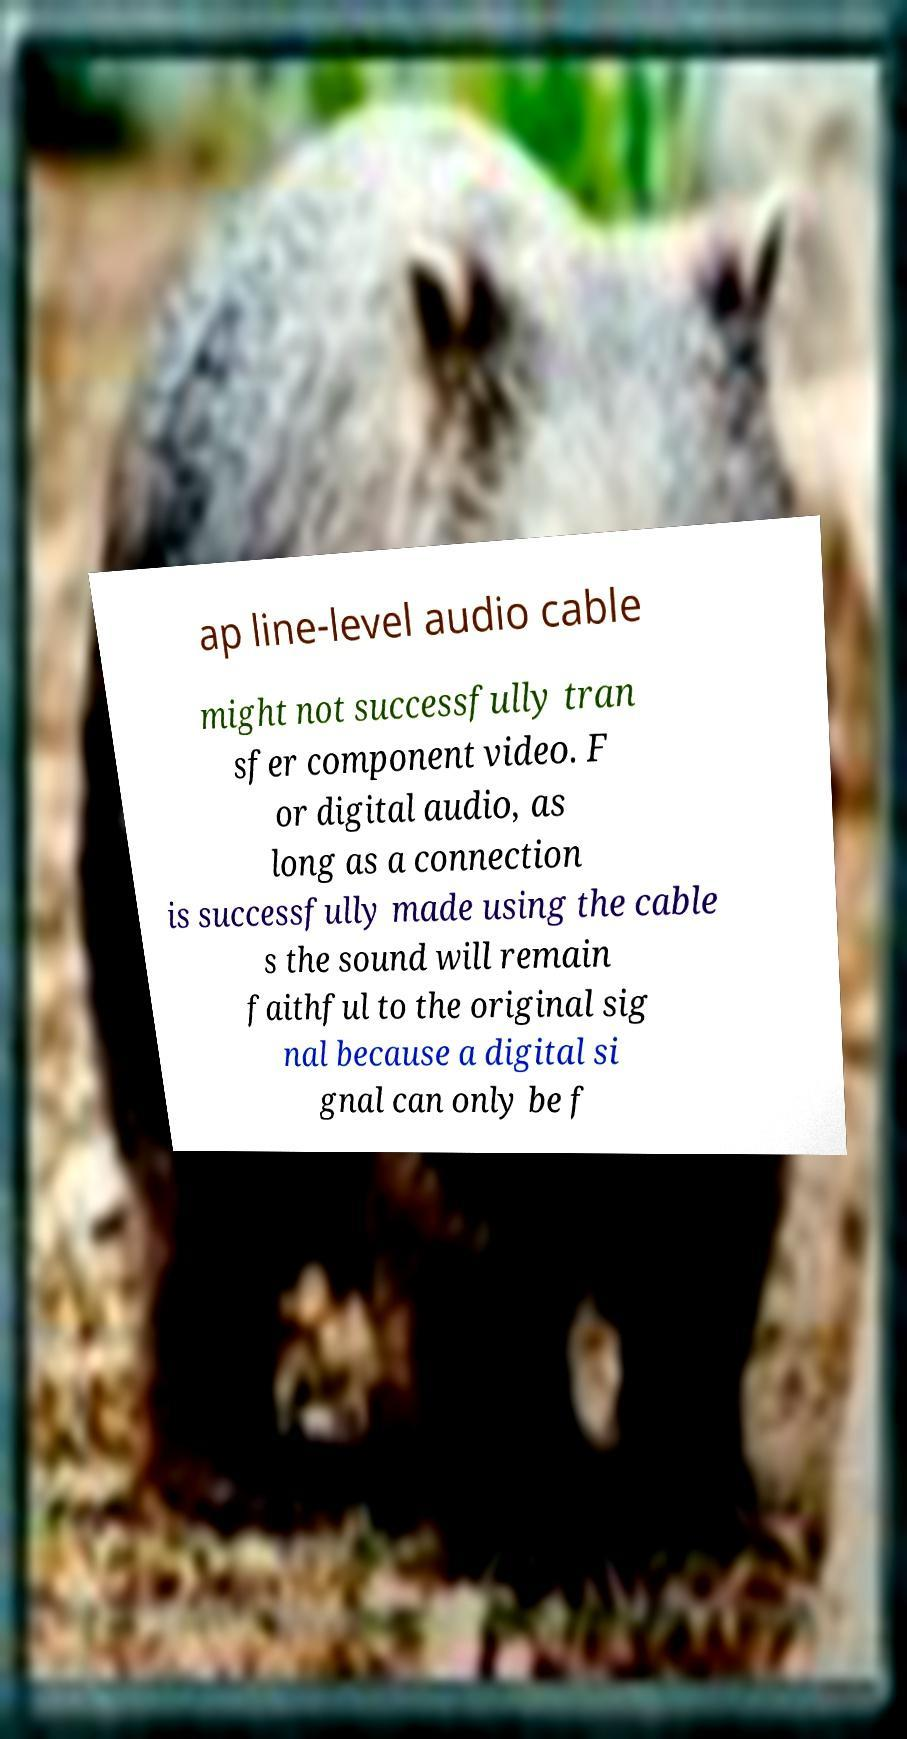Can you read and provide the text displayed in the image?This photo seems to have some interesting text. Can you extract and type it out for me? ap line-level audio cable might not successfully tran sfer component video. F or digital audio, as long as a connection is successfully made using the cable s the sound will remain faithful to the original sig nal because a digital si gnal can only be f 